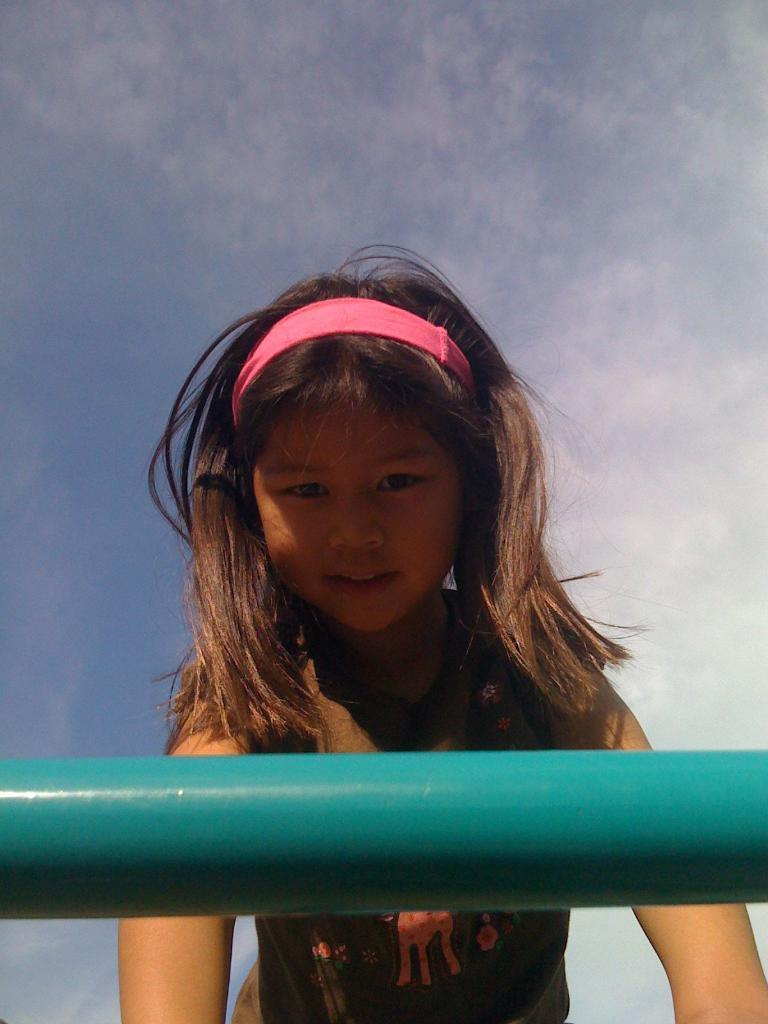Who is the main subject in the image? There is a girl in the image. What can be seen in the background of the image? There is a road and sky visible in the image. What is the condition of the sky in the image? Clouds are present in the sky. How many goldfish can be seen swimming in the sky in the image? There are no goldfish present in the image; it features a girl, a road, and a sky with clouds. 